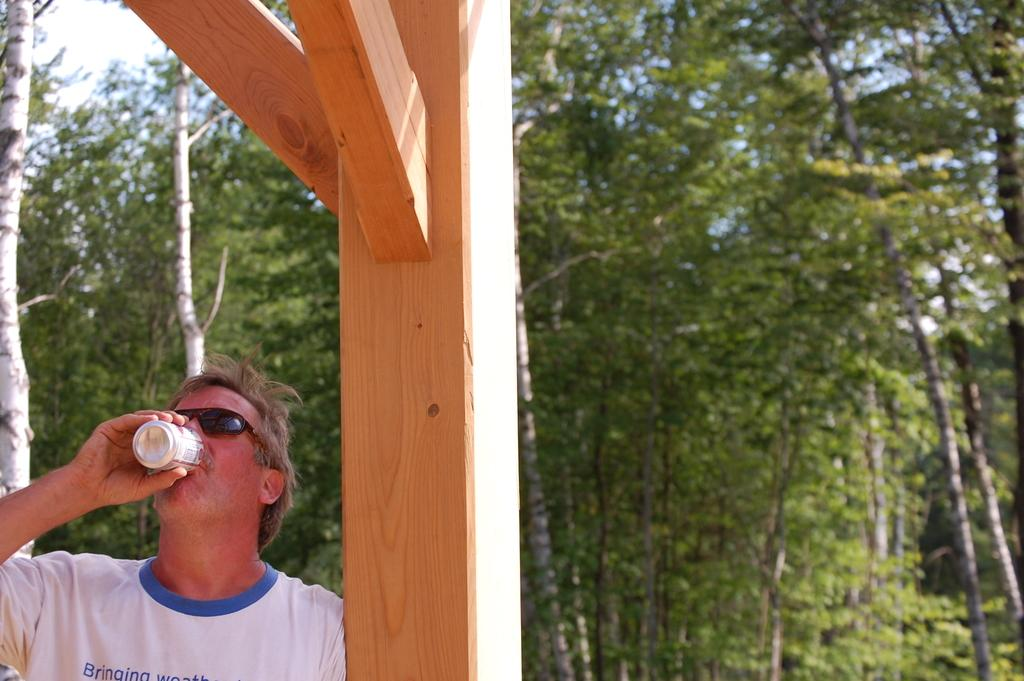What is the man on the left side of the image doing? The man is holding a tin and drinking from it. What can be seen in the background of the image? There are trees in the background of the image. What type of afterthought is the man having while drinking from the tin? There is no indication of any afterthought in the image, as the man is simply drinking from the tin. 